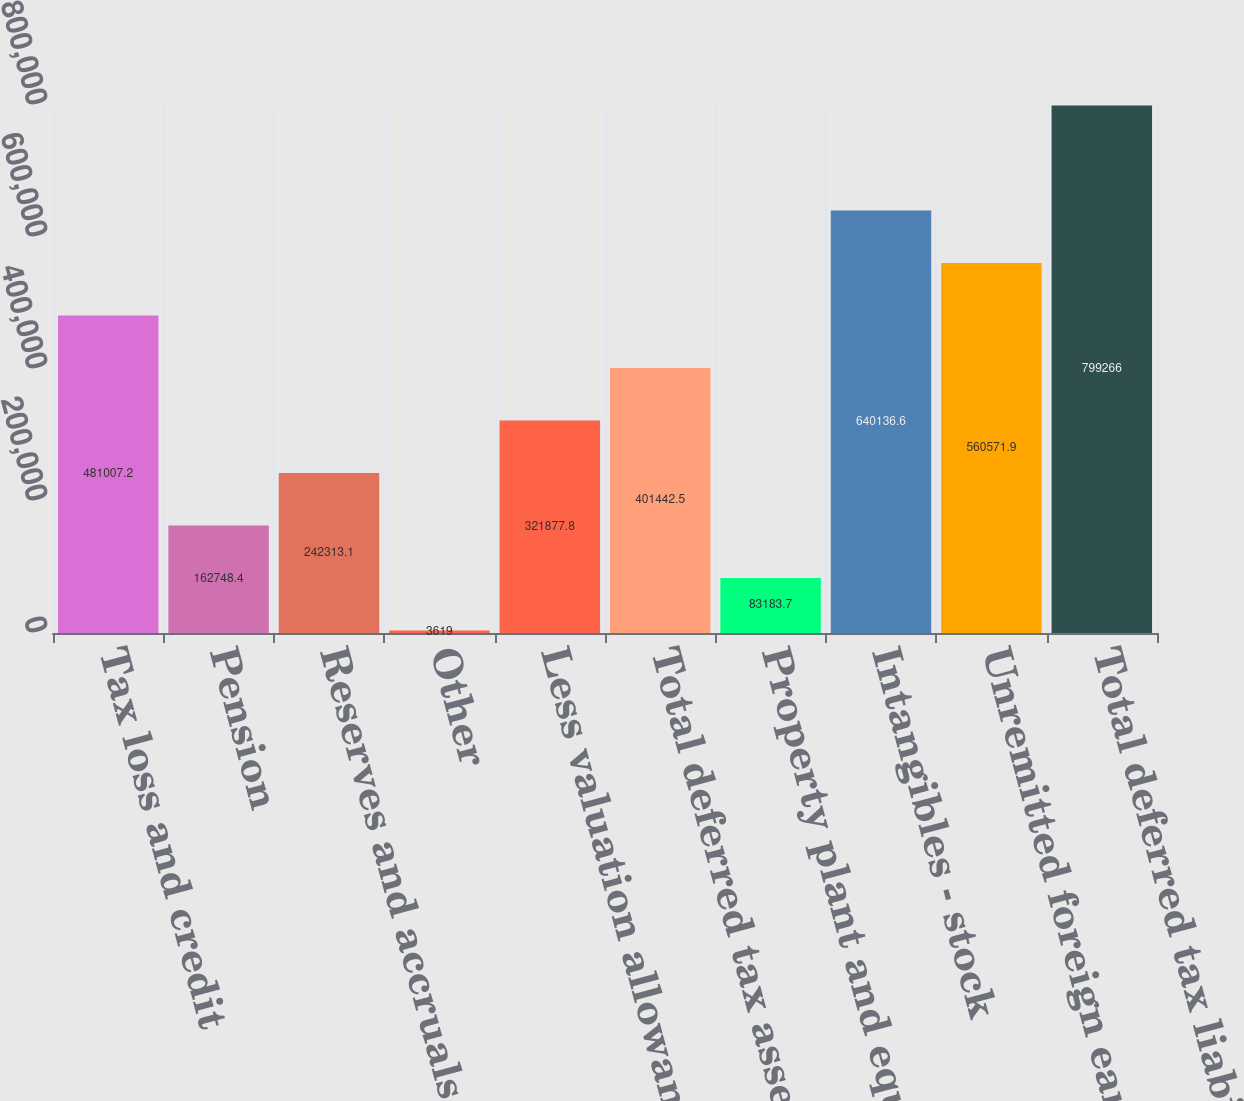Convert chart to OTSL. <chart><loc_0><loc_0><loc_500><loc_500><bar_chart><fcel>Tax loss and credit<fcel>Pension<fcel>Reserves and accruals<fcel>Other<fcel>Less valuation allowances<fcel>Total deferred tax assets<fcel>Property plant and equipment<fcel>Intangibles - stock<fcel>Unremitted foreign earnings<fcel>Total deferred tax liabilities<nl><fcel>481007<fcel>162748<fcel>242313<fcel>3619<fcel>321878<fcel>401442<fcel>83183.7<fcel>640137<fcel>560572<fcel>799266<nl></chart> 